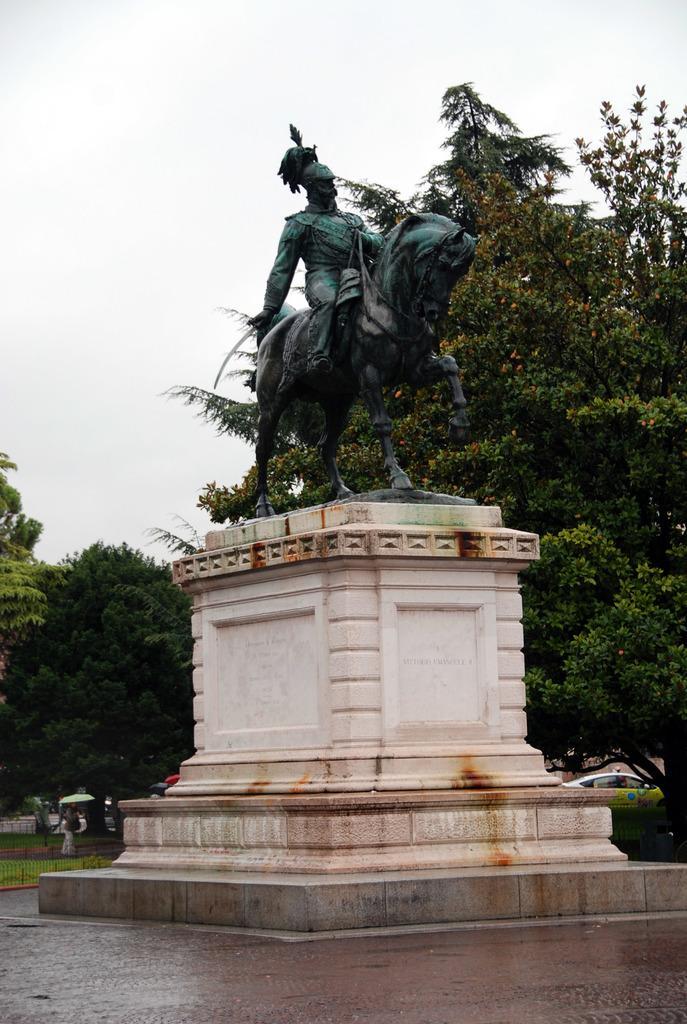How would you summarize this image in a sentence or two? In this image we can see the statue of a person and a horse. There are many trees in the image. There is a grassy land in the image. There is a fence in the image. We can see the sky in the image. There are few people at the left side of the image. There is a car at the right side of the image. 